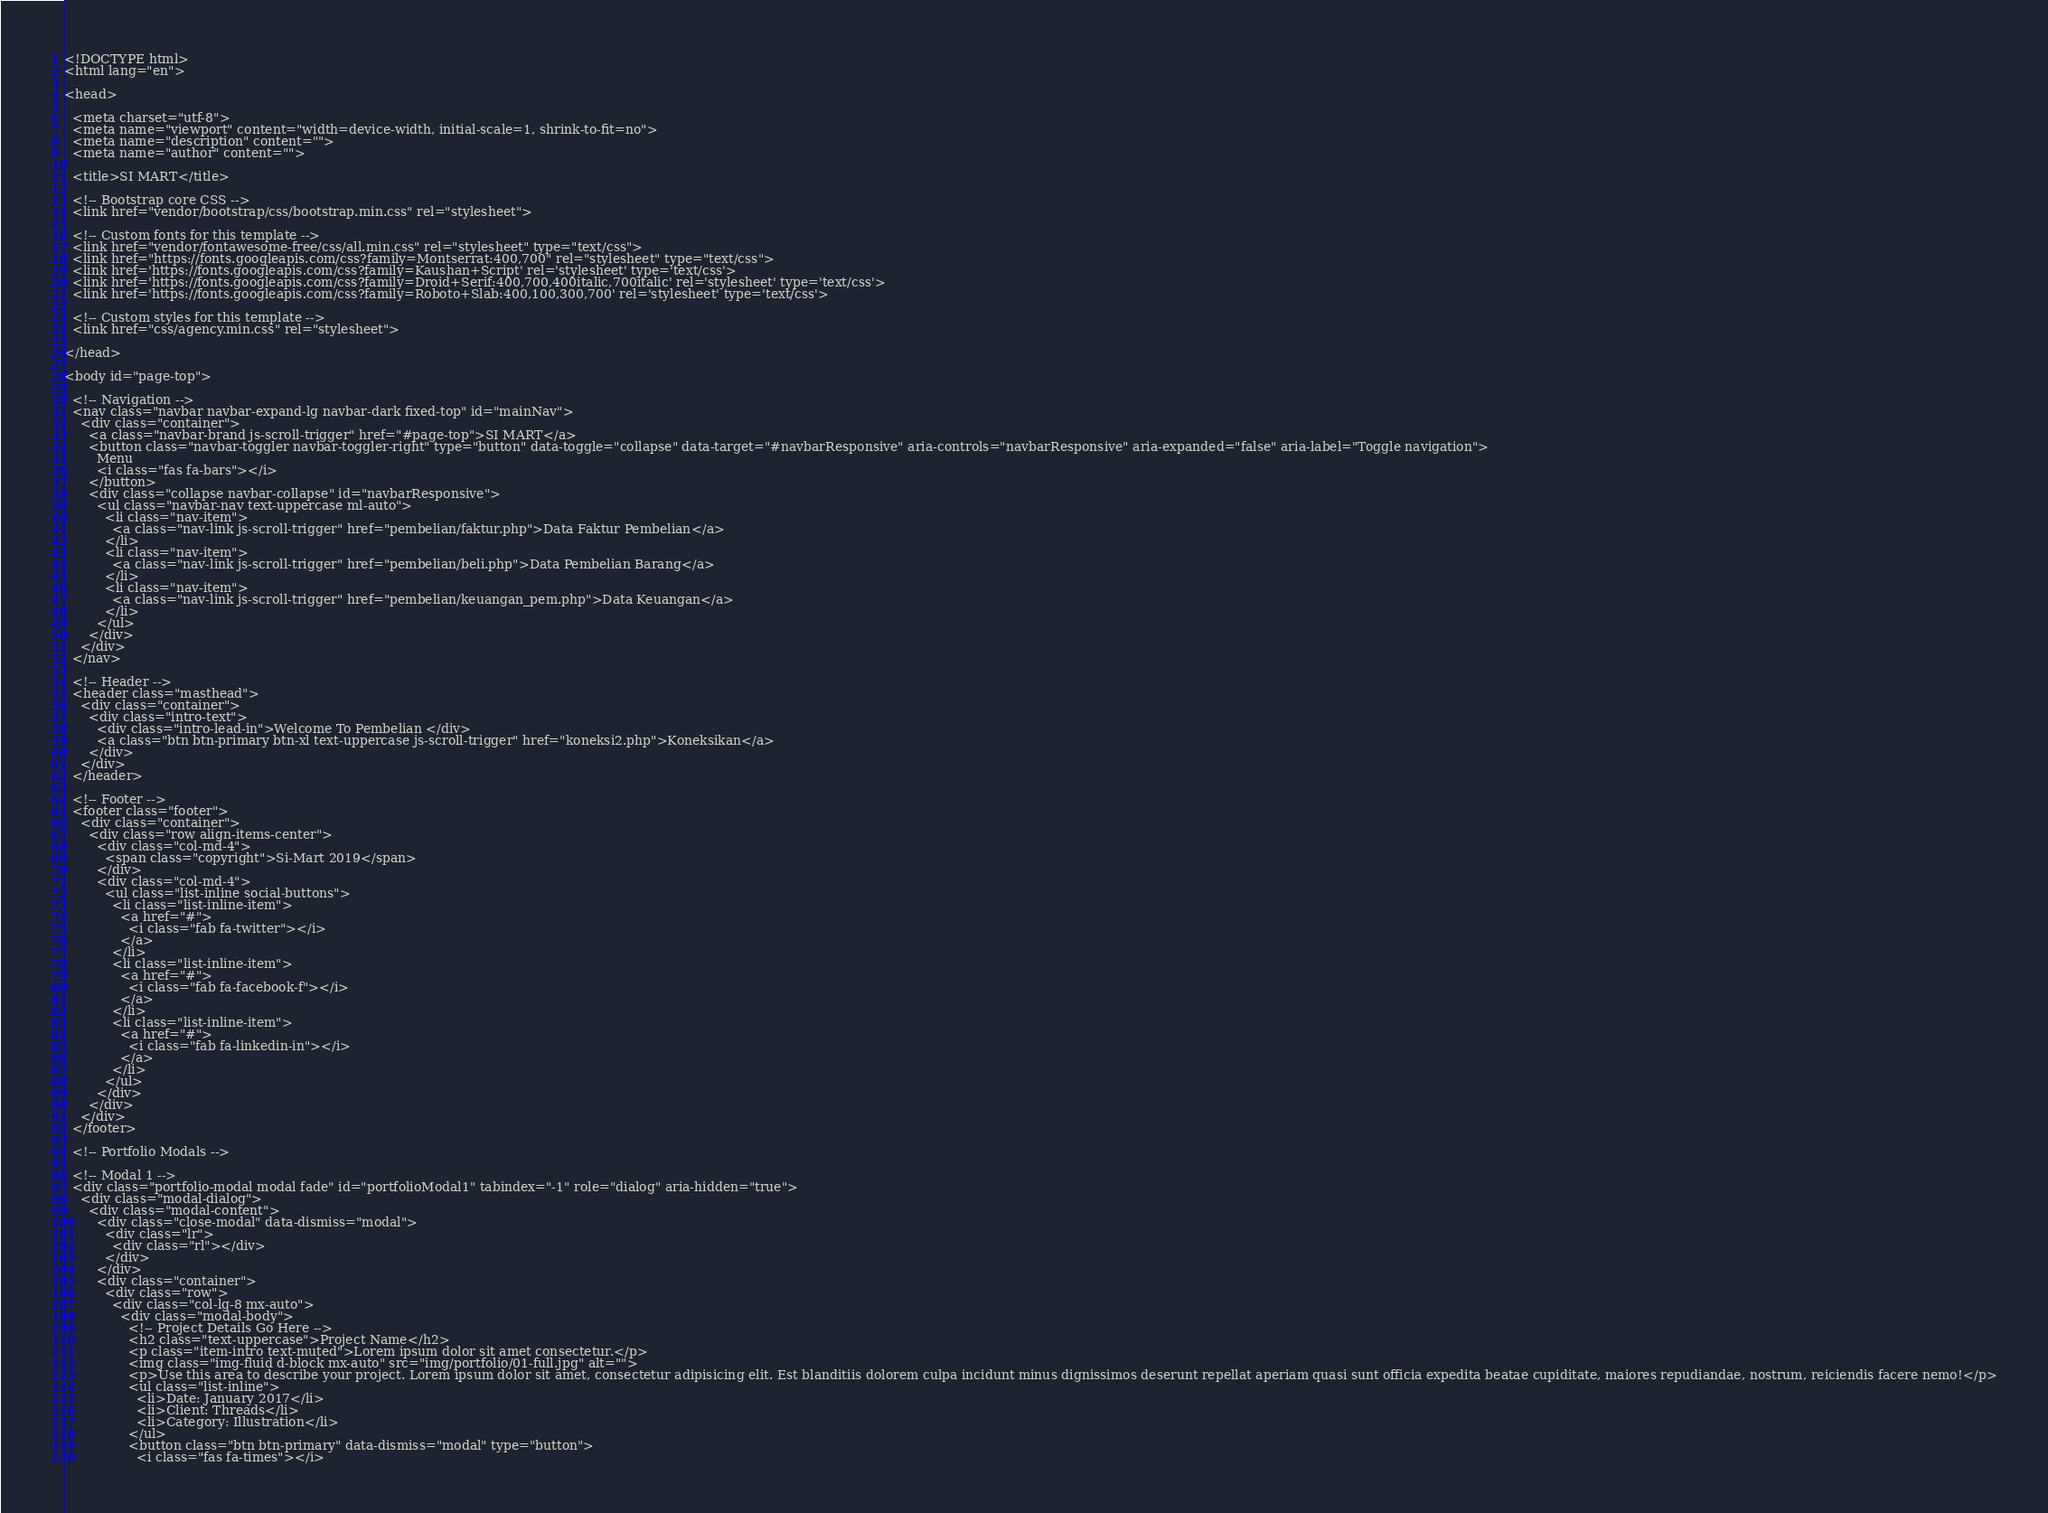<code> <loc_0><loc_0><loc_500><loc_500><_PHP_><!DOCTYPE html>
<html lang="en">

<head>

  <meta charset="utf-8">
  <meta name="viewport" content="width=device-width, initial-scale=1, shrink-to-fit=no">
  <meta name="description" content="">
  <meta name="author" content="">

  <title>SI MART</title>

  <!-- Bootstrap core CSS -->
  <link href="vendor/bootstrap/css/bootstrap.min.css" rel="stylesheet">

  <!-- Custom fonts for this template -->
  <link href="vendor/fontawesome-free/css/all.min.css" rel="stylesheet" type="text/css">
  <link href="https://fonts.googleapis.com/css?family=Montserrat:400,700" rel="stylesheet" type="text/css">
  <link href='https://fonts.googleapis.com/css?family=Kaushan+Script' rel='stylesheet' type='text/css'>
  <link href='https://fonts.googleapis.com/css?family=Droid+Serif:400,700,400italic,700italic' rel='stylesheet' type='text/css'>
  <link href='https://fonts.googleapis.com/css?family=Roboto+Slab:400,100,300,700' rel='stylesheet' type='text/css'>

  <!-- Custom styles for this template -->
  <link href="css/agency.min.css" rel="stylesheet">

</head>

<body id="page-top">

  <!-- Navigation -->
  <nav class="navbar navbar-expand-lg navbar-dark fixed-top" id="mainNav">
    <div class="container">
      <a class="navbar-brand js-scroll-trigger" href="#page-top">SI MART</a>
      <button class="navbar-toggler navbar-toggler-right" type="button" data-toggle="collapse" data-target="#navbarResponsive" aria-controls="navbarResponsive" aria-expanded="false" aria-label="Toggle navigation">
        Menu
        <i class="fas fa-bars"></i>
      </button>
      <div class="collapse navbar-collapse" id="navbarResponsive">
        <ul class="navbar-nav text-uppercase ml-auto">
          <li class="nav-item">
            <a class="nav-link js-scroll-trigger" href="pembelian/faktur.php">Data Faktur Pembelian</a>
          </li>
          <li class="nav-item">
            <a class="nav-link js-scroll-trigger" href="pembelian/beli.php">Data Pembelian Barang</a>
          </li>
          <li class="nav-item">
            <a class="nav-link js-scroll-trigger" href="pembelian/keuangan_pem.php">Data Keuangan</a>
          </li>
        </ul>
      </div>
    </div>
  </nav>

  <!-- Header -->
  <header class="masthead">
    <div class="container">
      <div class="intro-text">
        <div class="intro-lead-in">Welcome To Pembelian </div>
        <a class="btn btn-primary btn-xl text-uppercase js-scroll-trigger" href="koneksi2.php">Koneksikan</a>
      </div>
    </div>
  </header>

  <!-- Footer -->
  <footer class="footer">
    <div class="container">
      <div class="row align-items-center">
        <div class="col-md-4">
          <span class="copyright">Si-Mart 2019</span>
        </div>
        <div class="col-md-4">
          <ul class="list-inline social-buttons">
            <li class="list-inline-item">
              <a href="#">
                <i class="fab fa-twitter"></i>
              </a>
            </li>
            <li class="list-inline-item">
              <a href="#">
                <i class="fab fa-facebook-f"></i>
              </a>
            </li>
            <li class="list-inline-item">
              <a href="#">
                <i class="fab fa-linkedin-in"></i>
              </a>
            </li>
          </ul>
        </div>
      </div>
    </div>
  </footer>

  <!-- Portfolio Modals -->

  <!-- Modal 1 -->
  <div class="portfolio-modal modal fade" id="portfolioModal1" tabindex="-1" role="dialog" aria-hidden="true">
    <div class="modal-dialog">
      <div class="modal-content">
        <div class="close-modal" data-dismiss="modal">
          <div class="lr">
            <div class="rl"></div>
          </div>
        </div>
        <div class="container">
          <div class="row">
            <div class="col-lg-8 mx-auto">
              <div class="modal-body">
                <!-- Project Details Go Here -->
                <h2 class="text-uppercase">Project Name</h2>
                <p class="item-intro text-muted">Lorem ipsum dolor sit amet consectetur.</p>
                <img class="img-fluid d-block mx-auto" src="img/portfolio/01-full.jpg" alt="">
                <p>Use this area to describe your project. Lorem ipsum dolor sit amet, consectetur adipisicing elit. Est blanditiis dolorem culpa incidunt minus dignissimos deserunt repellat aperiam quasi sunt officia expedita beatae cupiditate, maiores repudiandae, nostrum, reiciendis facere nemo!</p>
                <ul class="list-inline">
                  <li>Date: January 2017</li>
                  <li>Client: Threads</li>
                  <li>Category: Illustration</li>
                </ul>
                <button class="btn btn-primary" data-dismiss="modal" type="button">
                  <i class="fas fa-times"></i></code> 